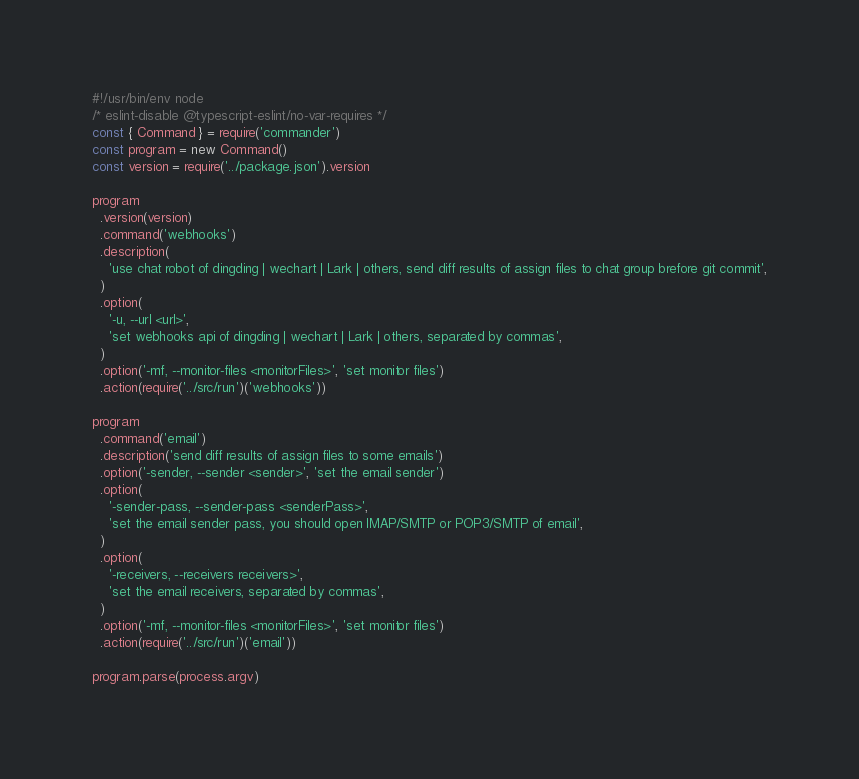<code> <loc_0><loc_0><loc_500><loc_500><_JavaScript_>#!/usr/bin/env node
/* eslint-disable @typescript-eslint/no-var-requires */
const { Command } = require('commander')
const program = new Command()
const version = require('../package.json').version

program
  .version(version)
  .command('webhooks')
  .description(
    'use chat robot of dingding | wechart | Lark | others, send diff results of assign files to chat group brefore git commit',
  )
  .option(
    '-u, --url <url>',
    'set webhooks api of dingding | wechart | Lark | others, separated by commas',
  )
  .option('-mf, --monitor-files <monitorFiles>', 'set monitor files')
  .action(require('../src/run')('webhooks'))

program
  .command('email')
  .description('send diff results of assign files to some emails')
  .option('-sender, --sender <sender>', 'set the email sender')
  .option(
    '-sender-pass, --sender-pass <senderPass>',
    'set the email sender pass, you should open lMAP/SMTP or POP3/SMTP of email',
  )
  .option(
    '-receivers, --receivers receivers>',
    'set the email receivers, separated by commas',
  )
  .option('-mf, --monitor-files <monitorFiles>', 'set monitor files')
  .action(require('../src/run')('email'))

program.parse(process.argv)
</code> 